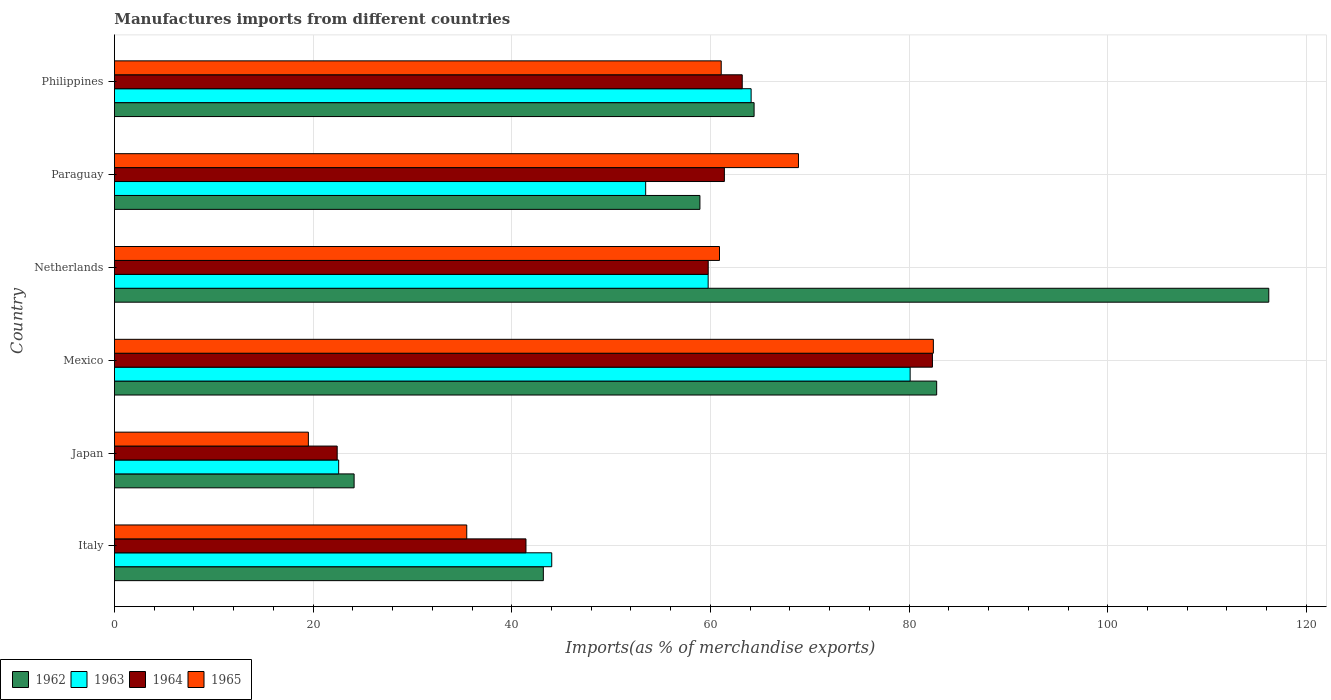How many different coloured bars are there?
Offer a terse response. 4. How many groups of bars are there?
Provide a succinct answer. 6. Are the number of bars per tick equal to the number of legend labels?
Give a very brief answer. Yes. How many bars are there on the 3rd tick from the top?
Offer a very short reply. 4. How many bars are there on the 4th tick from the bottom?
Give a very brief answer. 4. What is the label of the 4th group of bars from the top?
Your response must be concise. Mexico. What is the percentage of imports to different countries in 1964 in Italy?
Your answer should be compact. 41.43. Across all countries, what is the maximum percentage of imports to different countries in 1964?
Provide a succinct answer. 82.35. Across all countries, what is the minimum percentage of imports to different countries in 1962?
Your answer should be very brief. 24.13. In which country was the percentage of imports to different countries in 1965 maximum?
Your answer should be compact. Mexico. In which country was the percentage of imports to different countries in 1964 minimum?
Make the answer very short. Japan. What is the total percentage of imports to different countries in 1963 in the graph?
Offer a terse response. 324.06. What is the difference between the percentage of imports to different countries in 1962 in Japan and that in Paraguay?
Ensure brevity in your answer.  -34.81. What is the difference between the percentage of imports to different countries in 1963 in Italy and the percentage of imports to different countries in 1962 in Mexico?
Offer a very short reply. -38.75. What is the average percentage of imports to different countries in 1965 per country?
Give a very brief answer. 54.72. What is the difference between the percentage of imports to different countries in 1963 and percentage of imports to different countries in 1962 in Japan?
Give a very brief answer. -1.55. In how many countries, is the percentage of imports to different countries in 1962 greater than 92 %?
Your answer should be compact. 1. What is the ratio of the percentage of imports to different countries in 1963 in Netherlands to that in Paraguay?
Make the answer very short. 1.12. Is the percentage of imports to different countries in 1964 in Italy less than that in Netherlands?
Provide a short and direct response. Yes. What is the difference between the highest and the second highest percentage of imports to different countries in 1963?
Your response must be concise. 16.01. What is the difference between the highest and the lowest percentage of imports to different countries in 1965?
Provide a short and direct response. 62.92. In how many countries, is the percentage of imports to different countries in 1963 greater than the average percentage of imports to different countries in 1963 taken over all countries?
Your response must be concise. 3. Is it the case that in every country, the sum of the percentage of imports to different countries in 1965 and percentage of imports to different countries in 1962 is greater than the sum of percentage of imports to different countries in 1964 and percentage of imports to different countries in 1963?
Your response must be concise. No. What does the 4th bar from the top in Netherlands represents?
Provide a short and direct response. 1962. How many bars are there?
Offer a terse response. 24. How many countries are there in the graph?
Offer a terse response. 6. What is the difference between two consecutive major ticks on the X-axis?
Ensure brevity in your answer.  20. Does the graph contain any zero values?
Provide a short and direct response. No. Does the graph contain grids?
Keep it short and to the point. Yes. Where does the legend appear in the graph?
Provide a succinct answer. Bottom left. What is the title of the graph?
Keep it short and to the point. Manufactures imports from different countries. Does "1994" appear as one of the legend labels in the graph?
Ensure brevity in your answer.  No. What is the label or title of the X-axis?
Your answer should be compact. Imports(as % of merchandise exports). What is the label or title of the Y-axis?
Offer a very short reply. Country. What is the Imports(as % of merchandise exports) in 1962 in Italy?
Your response must be concise. 43.18. What is the Imports(as % of merchandise exports) in 1963 in Italy?
Provide a succinct answer. 44.02. What is the Imports(as % of merchandise exports) of 1964 in Italy?
Offer a very short reply. 41.43. What is the Imports(as % of merchandise exports) in 1965 in Italy?
Your response must be concise. 35.47. What is the Imports(as % of merchandise exports) of 1962 in Japan?
Keep it short and to the point. 24.13. What is the Imports(as % of merchandise exports) of 1963 in Japan?
Offer a very short reply. 22.57. What is the Imports(as % of merchandise exports) of 1964 in Japan?
Your answer should be very brief. 22.43. What is the Imports(as % of merchandise exports) of 1965 in Japan?
Offer a terse response. 19.52. What is the Imports(as % of merchandise exports) of 1962 in Mexico?
Provide a short and direct response. 82.78. What is the Imports(as % of merchandise exports) of 1963 in Mexico?
Ensure brevity in your answer.  80.11. What is the Imports(as % of merchandise exports) in 1964 in Mexico?
Provide a succinct answer. 82.35. What is the Imports(as % of merchandise exports) of 1965 in Mexico?
Offer a very short reply. 82.44. What is the Imports(as % of merchandise exports) in 1962 in Netherlands?
Offer a very short reply. 116.21. What is the Imports(as % of merchandise exports) in 1963 in Netherlands?
Your answer should be very brief. 59.77. What is the Imports(as % of merchandise exports) of 1964 in Netherlands?
Ensure brevity in your answer.  59.78. What is the Imports(as % of merchandise exports) in 1965 in Netherlands?
Give a very brief answer. 60.91. What is the Imports(as % of merchandise exports) in 1962 in Paraguay?
Give a very brief answer. 58.94. What is the Imports(as % of merchandise exports) in 1963 in Paraguay?
Keep it short and to the point. 53.48. What is the Imports(as % of merchandise exports) in 1964 in Paraguay?
Your answer should be very brief. 61.4. What is the Imports(as % of merchandise exports) in 1965 in Paraguay?
Make the answer very short. 68.86. What is the Imports(as % of merchandise exports) in 1962 in Philippines?
Offer a very short reply. 64.4. What is the Imports(as % of merchandise exports) in 1963 in Philippines?
Offer a very short reply. 64.1. What is the Imports(as % of merchandise exports) of 1964 in Philippines?
Ensure brevity in your answer.  63.2. What is the Imports(as % of merchandise exports) of 1965 in Philippines?
Keep it short and to the point. 61.09. Across all countries, what is the maximum Imports(as % of merchandise exports) of 1962?
Your answer should be very brief. 116.21. Across all countries, what is the maximum Imports(as % of merchandise exports) in 1963?
Your answer should be compact. 80.11. Across all countries, what is the maximum Imports(as % of merchandise exports) of 1964?
Offer a terse response. 82.35. Across all countries, what is the maximum Imports(as % of merchandise exports) of 1965?
Offer a very short reply. 82.44. Across all countries, what is the minimum Imports(as % of merchandise exports) in 1962?
Keep it short and to the point. 24.13. Across all countries, what is the minimum Imports(as % of merchandise exports) of 1963?
Offer a terse response. 22.57. Across all countries, what is the minimum Imports(as % of merchandise exports) of 1964?
Offer a very short reply. 22.43. Across all countries, what is the minimum Imports(as % of merchandise exports) of 1965?
Offer a very short reply. 19.52. What is the total Imports(as % of merchandise exports) of 1962 in the graph?
Your response must be concise. 389.64. What is the total Imports(as % of merchandise exports) of 1963 in the graph?
Your answer should be compact. 324.06. What is the total Imports(as % of merchandise exports) in 1964 in the graph?
Provide a succinct answer. 330.59. What is the total Imports(as % of merchandise exports) of 1965 in the graph?
Make the answer very short. 328.3. What is the difference between the Imports(as % of merchandise exports) in 1962 in Italy and that in Japan?
Make the answer very short. 19.05. What is the difference between the Imports(as % of merchandise exports) in 1963 in Italy and that in Japan?
Provide a succinct answer. 21.45. What is the difference between the Imports(as % of merchandise exports) in 1964 in Italy and that in Japan?
Offer a very short reply. 19. What is the difference between the Imports(as % of merchandise exports) in 1965 in Italy and that in Japan?
Offer a terse response. 15.94. What is the difference between the Imports(as % of merchandise exports) in 1962 in Italy and that in Mexico?
Keep it short and to the point. -39.6. What is the difference between the Imports(as % of merchandise exports) of 1963 in Italy and that in Mexico?
Your answer should be very brief. -36.08. What is the difference between the Imports(as % of merchandise exports) of 1964 in Italy and that in Mexico?
Your answer should be compact. -40.92. What is the difference between the Imports(as % of merchandise exports) in 1965 in Italy and that in Mexico?
Give a very brief answer. -46.98. What is the difference between the Imports(as % of merchandise exports) of 1962 in Italy and that in Netherlands?
Give a very brief answer. -73.03. What is the difference between the Imports(as % of merchandise exports) of 1963 in Italy and that in Netherlands?
Provide a short and direct response. -15.75. What is the difference between the Imports(as % of merchandise exports) of 1964 in Italy and that in Netherlands?
Give a very brief answer. -18.35. What is the difference between the Imports(as % of merchandise exports) of 1965 in Italy and that in Netherlands?
Your answer should be very brief. -25.45. What is the difference between the Imports(as % of merchandise exports) of 1962 in Italy and that in Paraguay?
Provide a succinct answer. -15.76. What is the difference between the Imports(as % of merchandise exports) of 1963 in Italy and that in Paraguay?
Offer a terse response. -9.46. What is the difference between the Imports(as % of merchandise exports) in 1964 in Italy and that in Paraguay?
Keep it short and to the point. -19.97. What is the difference between the Imports(as % of merchandise exports) in 1965 in Italy and that in Paraguay?
Make the answer very short. -33.4. What is the difference between the Imports(as % of merchandise exports) of 1962 in Italy and that in Philippines?
Offer a terse response. -21.22. What is the difference between the Imports(as % of merchandise exports) of 1963 in Italy and that in Philippines?
Your answer should be very brief. -20.07. What is the difference between the Imports(as % of merchandise exports) in 1964 in Italy and that in Philippines?
Provide a short and direct response. -21.77. What is the difference between the Imports(as % of merchandise exports) in 1965 in Italy and that in Philippines?
Ensure brevity in your answer.  -25.62. What is the difference between the Imports(as % of merchandise exports) of 1962 in Japan and that in Mexico?
Give a very brief answer. -58.65. What is the difference between the Imports(as % of merchandise exports) in 1963 in Japan and that in Mexico?
Provide a short and direct response. -57.53. What is the difference between the Imports(as % of merchandise exports) in 1964 in Japan and that in Mexico?
Offer a very short reply. -59.92. What is the difference between the Imports(as % of merchandise exports) of 1965 in Japan and that in Mexico?
Your answer should be very brief. -62.92. What is the difference between the Imports(as % of merchandise exports) of 1962 in Japan and that in Netherlands?
Your response must be concise. -92.08. What is the difference between the Imports(as % of merchandise exports) of 1963 in Japan and that in Netherlands?
Make the answer very short. -37.2. What is the difference between the Imports(as % of merchandise exports) in 1964 in Japan and that in Netherlands?
Your answer should be compact. -37.35. What is the difference between the Imports(as % of merchandise exports) in 1965 in Japan and that in Netherlands?
Make the answer very short. -41.39. What is the difference between the Imports(as % of merchandise exports) in 1962 in Japan and that in Paraguay?
Your answer should be very brief. -34.81. What is the difference between the Imports(as % of merchandise exports) of 1963 in Japan and that in Paraguay?
Offer a very short reply. -30.91. What is the difference between the Imports(as % of merchandise exports) of 1964 in Japan and that in Paraguay?
Offer a very short reply. -38.98. What is the difference between the Imports(as % of merchandise exports) of 1965 in Japan and that in Paraguay?
Offer a terse response. -49.34. What is the difference between the Imports(as % of merchandise exports) in 1962 in Japan and that in Philippines?
Your answer should be compact. -40.27. What is the difference between the Imports(as % of merchandise exports) in 1963 in Japan and that in Philippines?
Ensure brevity in your answer.  -41.52. What is the difference between the Imports(as % of merchandise exports) of 1964 in Japan and that in Philippines?
Ensure brevity in your answer.  -40.78. What is the difference between the Imports(as % of merchandise exports) of 1965 in Japan and that in Philippines?
Your response must be concise. -41.56. What is the difference between the Imports(as % of merchandise exports) of 1962 in Mexico and that in Netherlands?
Make the answer very short. -33.43. What is the difference between the Imports(as % of merchandise exports) of 1963 in Mexico and that in Netherlands?
Give a very brief answer. 20.34. What is the difference between the Imports(as % of merchandise exports) in 1964 in Mexico and that in Netherlands?
Your answer should be very brief. 22.57. What is the difference between the Imports(as % of merchandise exports) in 1965 in Mexico and that in Netherlands?
Provide a short and direct response. 21.53. What is the difference between the Imports(as % of merchandise exports) of 1962 in Mexico and that in Paraguay?
Your answer should be compact. 23.83. What is the difference between the Imports(as % of merchandise exports) of 1963 in Mexico and that in Paraguay?
Your answer should be compact. 26.63. What is the difference between the Imports(as % of merchandise exports) in 1964 in Mexico and that in Paraguay?
Your answer should be very brief. 20.95. What is the difference between the Imports(as % of merchandise exports) in 1965 in Mexico and that in Paraguay?
Your answer should be compact. 13.58. What is the difference between the Imports(as % of merchandise exports) in 1962 in Mexico and that in Philippines?
Provide a short and direct response. 18.38. What is the difference between the Imports(as % of merchandise exports) of 1963 in Mexico and that in Philippines?
Your response must be concise. 16.01. What is the difference between the Imports(as % of merchandise exports) in 1964 in Mexico and that in Philippines?
Keep it short and to the point. 19.15. What is the difference between the Imports(as % of merchandise exports) in 1965 in Mexico and that in Philippines?
Your response must be concise. 21.36. What is the difference between the Imports(as % of merchandise exports) in 1962 in Netherlands and that in Paraguay?
Keep it short and to the point. 57.27. What is the difference between the Imports(as % of merchandise exports) of 1963 in Netherlands and that in Paraguay?
Provide a succinct answer. 6.29. What is the difference between the Imports(as % of merchandise exports) of 1964 in Netherlands and that in Paraguay?
Your answer should be very brief. -1.63. What is the difference between the Imports(as % of merchandise exports) in 1965 in Netherlands and that in Paraguay?
Give a very brief answer. -7.95. What is the difference between the Imports(as % of merchandise exports) in 1962 in Netherlands and that in Philippines?
Provide a succinct answer. 51.81. What is the difference between the Imports(as % of merchandise exports) in 1963 in Netherlands and that in Philippines?
Keep it short and to the point. -4.33. What is the difference between the Imports(as % of merchandise exports) of 1964 in Netherlands and that in Philippines?
Your answer should be compact. -3.42. What is the difference between the Imports(as % of merchandise exports) of 1965 in Netherlands and that in Philippines?
Your answer should be very brief. -0.17. What is the difference between the Imports(as % of merchandise exports) of 1962 in Paraguay and that in Philippines?
Your response must be concise. -5.45. What is the difference between the Imports(as % of merchandise exports) in 1963 in Paraguay and that in Philippines?
Offer a terse response. -10.62. What is the difference between the Imports(as % of merchandise exports) in 1964 in Paraguay and that in Philippines?
Provide a succinct answer. -1.8. What is the difference between the Imports(as % of merchandise exports) of 1965 in Paraguay and that in Philippines?
Give a very brief answer. 7.78. What is the difference between the Imports(as % of merchandise exports) of 1962 in Italy and the Imports(as % of merchandise exports) of 1963 in Japan?
Your answer should be very brief. 20.61. What is the difference between the Imports(as % of merchandise exports) in 1962 in Italy and the Imports(as % of merchandise exports) in 1964 in Japan?
Your response must be concise. 20.75. What is the difference between the Imports(as % of merchandise exports) in 1962 in Italy and the Imports(as % of merchandise exports) in 1965 in Japan?
Provide a short and direct response. 23.66. What is the difference between the Imports(as % of merchandise exports) in 1963 in Italy and the Imports(as % of merchandise exports) in 1964 in Japan?
Your answer should be compact. 21.6. What is the difference between the Imports(as % of merchandise exports) of 1963 in Italy and the Imports(as % of merchandise exports) of 1965 in Japan?
Make the answer very short. 24.5. What is the difference between the Imports(as % of merchandise exports) in 1964 in Italy and the Imports(as % of merchandise exports) in 1965 in Japan?
Ensure brevity in your answer.  21.91. What is the difference between the Imports(as % of merchandise exports) in 1962 in Italy and the Imports(as % of merchandise exports) in 1963 in Mexico?
Provide a succinct answer. -36.93. What is the difference between the Imports(as % of merchandise exports) of 1962 in Italy and the Imports(as % of merchandise exports) of 1964 in Mexico?
Offer a very short reply. -39.17. What is the difference between the Imports(as % of merchandise exports) in 1962 in Italy and the Imports(as % of merchandise exports) in 1965 in Mexico?
Make the answer very short. -39.26. What is the difference between the Imports(as % of merchandise exports) of 1963 in Italy and the Imports(as % of merchandise exports) of 1964 in Mexico?
Your answer should be compact. -38.33. What is the difference between the Imports(as % of merchandise exports) of 1963 in Italy and the Imports(as % of merchandise exports) of 1965 in Mexico?
Your answer should be compact. -38.42. What is the difference between the Imports(as % of merchandise exports) of 1964 in Italy and the Imports(as % of merchandise exports) of 1965 in Mexico?
Keep it short and to the point. -41.01. What is the difference between the Imports(as % of merchandise exports) in 1962 in Italy and the Imports(as % of merchandise exports) in 1963 in Netherlands?
Your response must be concise. -16.59. What is the difference between the Imports(as % of merchandise exports) of 1962 in Italy and the Imports(as % of merchandise exports) of 1964 in Netherlands?
Your answer should be very brief. -16.6. What is the difference between the Imports(as % of merchandise exports) of 1962 in Italy and the Imports(as % of merchandise exports) of 1965 in Netherlands?
Your answer should be very brief. -17.73. What is the difference between the Imports(as % of merchandise exports) in 1963 in Italy and the Imports(as % of merchandise exports) in 1964 in Netherlands?
Offer a terse response. -15.75. What is the difference between the Imports(as % of merchandise exports) of 1963 in Italy and the Imports(as % of merchandise exports) of 1965 in Netherlands?
Your response must be concise. -16.89. What is the difference between the Imports(as % of merchandise exports) of 1964 in Italy and the Imports(as % of merchandise exports) of 1965 in Netherlands?
Ensure brevity in your answer.  -19.48. What is the difference between the Imports(as % of merchandise exports) of 1962 in Italy and the Imports(as % of merchandise exports) of 1963 in Paraguay?
Your response must be concise. -10.3. What is the difference between the Imports(as % of merchandise exports) in 1962 in Italy and the Imports(as % of merchandise exports) in 1964 in Paraguay?
Make the answer very short. -18.22. What is the difference between the Imports(as % of merchandise exports) in 1962 in Italy and the Imports(as % of merchandise exports) in 1965 in Paraguay?
Your answer should be very brief. -25.68. What is the difference between the Imports(as % of merchandise exports) of 1963 in Italy and the Imports(as % of merchandise exports) of 1964 in Paraguay?
Provide a short and direct response. -17.38. What is the difference between the Imports(as % of merchandise exports) in 1963 in Italy and the Imports(as % of merchandise exports) in 1965 in Paraguay?
Give a very brief answer. -24.84. What is the difference between the Imports(as % of merchandise exports) in 1964 in Italy and the Imports(as % of merchandise exports) in 1965 in Paraguay?
Offer a very short reply. -27.43. What is the difference between the Imports(as % of merchandise exports) of 1962 in Italy and the Imports(as % of merchandise exports) of 1963 in Philippines?
Provide a short and direct response. -20.92. What is the difference between the Imports(as % of merchandise exports) in 1962 in Italy and the Imports(as % of merchandise exports) in 1964 in Philippines?
Your response must be concise. -20.02. What is the difference between the Imports(as % of merchandise exports) in 1962 in Italy and the Imports(as % of merchandise exports) in 1965 in Philippines?
Your answer should be compact. -17.91. What is the difference between the Imports(as % of merchandise exports) of 1963 in Italy and the Imports(as % of merchandise exports) of 1964 in Philippines?
Give a very brief answer. -19.18. What is the difference between the Imports(as % of merchandise exports) in 1963 in Italy and the Imports(as % of merchandise exports) in 1965 in Philippines?
Provide a succinct answer. -17.06. What is the difference between the Imports(as % of merchandise exports) in 1964 in Italy and the Imports(as % of merchandise exports) in 1965 in Philippines?
Keep it short and to the point. -19.66. What is the difference between the Imports(as % of merchandise exports) in 1962 in Japan and the Imports(as % of merchandise exports) in 1963 in Mexico?
Provide a short and direct response. -55.98. What is the difference between the Imports(as % of merchandise exports) of 1962 in Japan and the Imports(as % of merchandise exports) of 1964 in Mexico?
Provide a short and direct response. -58.22. What is the difference between the Imports(as % of merchandise exports) of 1962 in Japan and the Imports(as % of merchandise exports) of 1965 in Mexico?
Make the answer very short. -58.32. What is the difference between the Imports(as % of merchandise exports) in 1963 in Japan and the Imports(as % of merchandise exports) in 1964 in Mexico?
Make the answer very short. -59.78. What is the difference between the Imports(as % of merchandise exports) in 1963 in Japan and the Imports(as % of merchandise exports) in 1965 in Mexico?
Your answer should be very brief. -59.87. What is the difference between the Imports(as % of merchandise exports) of 1964 in Japan and the Imports(as % of merchandise exports) of 1965 in Mexico?
Provide a short and direct response. -60.02. What is the difference between the Imports(as % of merchandise exports) of 1962 in Japan and the Imports(as % of merchandise exports) of 1963 in Netherlands?
Offer a terse response. -35.64. What is the difference between the Imports(as % of merchandise exports) in 1962 in Japan and the Imports(as % of merchandise exports) in 1964 in Netherlands?
Keep it short and to the point. -35.65. What is the difference between the Imports(as % of merchandise exports) of 1962 in Japan and the Imports(as % of merchandise exports) of 1965 in Netherlands?
Your response must be concise. -36.79. What is the difference between the Imports(as % of merchandise exports) of 1963 in Japan and the Imports(as % of merchandise exports) of 1964 in Netherlands?
Ensure brevity in your answer.  -37.2. What is the difference between the Imports(as % of merchandise exports) in 1963 in Japan and the Imports(as % of merchandise exports) in 1965 in Netherlands?
Provide a succinct answer. -38.34. What is the difference between the Imports(as % of merchandise exports) in 1964 in Japan and the Imports(as % of merchandise exports) in 1965 in Netherlands?
Give a very brief answer. -38.49. What is the difference between the Imports(as % of merchandise exports) of 1962 in Japan and the Imports(as % of merchandise exports) of 1963 in Paraguay?
Provide a succinct answer. -29.35. What is the difference between the Imports(as % of merchandise exports) of 1962 in Japan and the Imports(as % of merchandise exports) of 1964 in Paraguay?
Give a very brief answer. -37.28. What is the difference between the Imports(as % of merchandise exports) in 1962 in Japan and the Imports(as % of merchandise exports) in 1965 in Paraguay?
Offer a very short reply. -44.74. What is the difference between the Imports(as % of merchandise exports) in 1963 in Japan and the Imports(as % of merchandise exports) in 1964 in Paraguay?
Make the answer very short. -38.83. What is the difference between the Imports(as % of merchandise exports) of 1963 in Japan and the Imports(as % of merchandise exports) of 1965 in Paraguay?
Give a very brief answer. -46.29. What is the difference between the Imports(as % of merchandise exports) in 1964 in Japan and the Imports(as % of merchandise exports) in 1965 in Paraguay?
Your answer should be very brief. -46.44. What is the difference between the Imports(as % of merchandise exports) of 1962 in Japan and the Imports(as % of merchandise exports) of 1963 in Philippines?
Make the answer very short. -39.97. What is the difference between the Imports(as % of merchandise exports) in 1962 in Japan and the Imports(as % of merchandise exports) in 1964 in Philippines?
Make the answer very short. -39.07. What is the difference between the Imports(as % of merchandise exports) in 1962 in Japan and the Imports(as % of merchandise exports) in 1965 in Philippines?
Ensure brevity in your answer.  -36.96. What is the difference between the Imports(as % of merchandise exports) in 1963 in Japan and the Imports(as % of merchandise exports) in 1964 in Philippines?
Offer a very short reply. -40.63. What is the difference between the Imports(as % of merchandise exports) of 1963 in Japan and the Imports(as % of merchandise exports) of 1965 in Philippines?
Your answer should be compact. -38.51. What is the difference between the Imports(as % of merchandise exports) in 1964 in Japan and the Imports(as % of merchandise exports) in 1965 in Philippines?
Offer a very short reply. -38.66. What is the difference between the Imports(as % of merchandise exports) of 1962 in Mexico and the Imports(as % of merchandise exports) of 1963 in Netherlands?
Your answer should be very brief. 23.01. What is the difference between the Imports(as % of merchandise exports) in 1962 in Mexico and the Imports(as % of merchandise exports) in 1964 in Netherlands?
Give a very brief answer. 23. What is the difference between the Imports(as % of merchandise exports) in 1962 in Mexico and the Imports(as % of merchandise exports) in 1965 in Netherlands?
Provide a succinct answer. 21.86. What is the difference between the Imports(as % of merchandise exports) of 1963 in Mexico and the Imports(as % of merchandise exports) of 1964 in Netherlands?
Offer a very short reply. 20.33. What is the difference between the Imports(as % of merchandise exports) in 1963 in Mexico and the Imports(as % of merchandise exports) in 1965 in Netherlands?
Offer a terse response. 19.19. What is the difference between the Imports(as % of merchandise exports) of 1964 in Mexico and the Imports(as % of merchandise exports) of 1965 in Netherlands?
Provide a succinct answer. 21.44. What is the difference between the Imports(as % of merchandise exports) of 1962 in Mexico and the Imports(as % of merchandise exports) of 1963 in Paraguay?
Your answer should be compact. 29.3. What is the difference between the Imports(as % of merchandise exports) in 1962 in Mexico and the Imports(as % of merchandise exports) in 1964 in Paraguay?
Your response must be concise. 21.37. What is the difference between the Imports(as % of merchandise exports) in 1962 in Mexico and the Imports(as % of merchandise exports) in 1965 in Paraguay?
Your response must be concise. 13.91. What is the difference between the Imports(as % of merchandise exports) of 1963 in Mexico and the Imports(as % of merchandise exports) of 1964 in Paraguay?
Make the answer very short. 18.7. What is the difference between the Imports(as % of merchandise exports) of 1963 in Mexico and the Imports(as % of merchandise exports) of 1965 in Paraguay?
Provide a short and direct response. 11.24. What is the difference between the Imports(as % of merchandise exports) of 1964 in Mexico and the Imports(as % of merchandise exports) of 1965 in Paraguay?
Make the answer very short. 13.49. What is the difference between the Imports(as % of merchandise exports) in 1962 in Mexico and the Imports(as % of merchandise exports) in 1963 in Philippines?
Make the answer very short. 18.68. What is the difference between the Imports(as % of merchandise exports) in 1962 in Mexico and the Imports(as % of merchandise exports) in 1964 in Philippines?
Give a very brief answer. 19.57. What is the difference between the Imports(as % of merchandise exports) of 1962 in Mexico and the Imports(as % of merchandise exports) of 1965 in Philippines?
Your response must be concise. 21.69. What is the difference between the Imports(as % of merchandise exports) in 1963 in Mexico and the Imports(as % of merchandise exports) in 1964 in Philippines?
Your response must be concise. 16.9. What is the difference between the Imports(as % of merchandise exports) in 1963 in Mexico and the Imports(as % of merchandise exports) in 1965 in Philippines?
Ensure brevity in your answer.  19.02. What is the difference between the Imports(as % of merchandise exports) of 1964 in Mexico and the Imports(as % of merchandise exports) of 1965 in Philippines?
Make the answer very short. 21.26. What is the difference between the Imports(as % of merchandise exports) of 1962 in Netherlands and the Imports(as % of merchandise exports) of 1963 in Paraguay?
Your answer should be compact. 62.73. What is the difference between the Imports(as % of merchandise exports) in 1962 in Netherlands and the Imports(as % of merchandise exports) in 1964 in Paraguay?
Your answer should be compact. 54.81. What is the difference between the Imports(as % of merchandise exports) in 1962 in Netherlands and the Imports(as % of merchandise exports) in 1965 in Paraguay?
Give a very brief answer. 47.35. What is the difference between the Imports(as % of merchandise exports) of 1963 in Netherlands and the Imports(as % of merchandise exports) of 1964 in Paraguay?
Your answer should be very brief. -1.63. What is the difference between the Imports(as % of merchandise exports) of 1963 in Netherlands and the Imports(as % of merchandise exports) of 1965 in Paraguay?
Your response must be concise. -9.09. What is the difference between the Imports(as % of merchandise exports) of 1964 in Netherlands and the Imports(as % of merchandise exports) of 1965 in Paraguay?
Provide a succinct answer. -9.09. What is the difference between the Imports(as % of merchandise exports) of 1962 in Netherlands and the Imports(as % of merchandise exports) of 1963 in Philippines?
Give a very brief answer. 52.11. What is the difference between the Imports(as % of merchandise exports) of 1962 in Netherlands and the Imports(as % of merchandise exports) of 1964 in Philippines?
Ensure brevity in your answer.  53.01. What is the difference between the Imports(as % of merchandise exports) in 1962 in Netherlands and the Imports(as % of merchandise exports) in 1965 in Philippines?
Provide a short and direct response. 55.12. What is the difference between the Imports(as % of merchandise exports) of 1963 in Netherlands and the Imports(as % of merchandise exports) of 1964 in Philippines?
Ensure brevity in your answer.  -3.43. What is the difference between the Imports(as % of merchandise exports) in 1963 in Netherlands and the Imports(as % of merchandise exports) in 1965 in Philippines?
Ensure brevity in your answer.  -1.32. What is the difference between the Imports(as % of merchandise exports) of 1964 in Netherlands and the Imports(as % of merchandise exports) of 1965 in Philippines?
Your answer should be very brief. -1.31. What is the difference between the Imports(as % of merchandise exports) of 1962 in Paraguay and the Imports(as % of merchandise exports) of 1963 in Philippines?
Provide a succinct answer. -5.15. What is the difference between the Imports(as % of merchandise exports) in 1962 in Paraguay and the Imports(as % of merchandise exports) in 1964 in Philippines?
Your response must be concise. -4.26. What is the difference between the Imports(as % of merchandise exports) in 1962 in Paraguay and the Imports(as % of merchandise exports) in 1965 in Philippines?
Ensure brevity in your answer.  -2.14. What is the difference between the Imports(as % of merchandise exports) of 1963 in Paraguay and the Imports(as % of merchandise exports) of 1964 in Philippines?
Offer a very short reply. -9.72. What is the difference between the Imports(as % of merchandise exports) in 1963 in Paraguay and the Imports(as % of merchandise exports) in 1965 in Philippines?
Your answer should be very brief. -7.61. What is the difference between the Imports(as % of merchandise exports) in 1964 in Paraguay and the Imports(as % of merchandise exports) in 1965 in Philippines?
Your response must be concise. 0.32. What is the average Imports(as % of merchandise exports) in 1962 per country?
Your answer should be compact. 64.94. What is the average Imports(as % of merchandise exports) of 1963 per country?
Your response must be concise. 54.01. What is the average Imports(as % of merchandise exports) in 1964 per country?
Offer a terse response. 55.1. What is the average Imports(as % of merchandise exports) of 1965 per country?
Ensure brevity in your answer.  54.72. What is the difference between the Imports(as % of merchandise exports) of 1962 and Imports(as % of merchandise exports) of 1963 in Italy?
Your answer should be very brief. -0.84. What is the difference between the Imports(as % of merchandise exports) of 1962 and Imports(as % of merchandise exports) of 1964 in Italy?
Your answer should be very brief. 1.75. What is the difference between the Imports(as % of merchandise exports) in 1962 and Imports(as % of merchandise exports) in 1965 in Italy?
Provide a short and direct response. 7.71. What is the difference between the Imports(as % of merchandise exports) in 1963 and Imports(as % of merchandise exports) in 1964 in Italy?
Keep it short and to the point. 2.59. What is the difference between the Imports(as % of merchandise exports) in 1963 and Imports(as % of merchandise exports) in 1965 in Italy?
Offer a very short reply. 8.56. What is the difference between the Imports(as % of merchandise exports) of 1964 and Imports(as % of merchandise exports) of 1965 in Italy?
Offer a terse response. 5.96. What is the difference between the Imports(as % of merchandise exports) in 1962 and Imports(as % of merchandise exports) in 1963 in Japan?
Provide a short and direct response. 1.55. What is the difference between the Imports(as % of merchandise exports) of 1962 and Imports(as % of merchandise exports) of 1964 in Japan?
Ensure brevity in your answer.  1.7. What is the difference between the Imports(as % of merchandise exports) of 1962 and Imports(as % of merchandise exports) of 1965 in Japan?
Ensure brevity in your answer.  4.6. What is the difference between the Imports(as % of merchandise exports) in 1963 and Imports(as % of merchandise exports) in 1964 in Japan?
Provide a succinct answer. 0.15. What is the difference between the Imports(as % of merchandise exports) in 1963 and Imports(as % of merchandise exports) in 1965 in Japan?
Keep it short and to the point. 3.05. What is the difference between the Imports(as % of merchandise exports) of 1964 and Imports(as % of merchandise exports) of 1965 in Japan?
Make the answer very short. 2.9. What is the difference between the Imports(as % of merchandise exports) in 1962 and Imports(as % of merchandise exports) in 1963 in Mexico?
Provide a succinct answer. 2.67. What is the difference between the Imports(as % of merchandise exports) of 1962 and Imports(as % of merchandise exports) of 1964 in Mexico?
Offer a terse response. 0.43. What is the difference between the Imports(as % of merchandise exports) in 1962 and Imports(as % of merchandise exports) in 1965 in Mexico?
Provide a short and direct response. 0.33. What is the difference between the Imports(as % of merchandise exports) in 1963 and Imports(as % of merchandise exports) in 1964 in Mexico?
Offer a very short reply. -2.24. What is the difference between the Imports(as % of merchandise exports) in 1963 and Imports(as % of merchandise exports) in 1965 in Mexico?
Your response must be concise. -2.34. What is the difference between the Imports(as % of merchandise exports) of 1964 and Imports(as % of merchandise exports) of 1965 in Mexico?
Provide a short and direct response. -0.09. What is the difference between the Imports(as % of merchandise exports) in 1962 and Imports(as % of merchandise exports) in 1963 in Netherlands?
Provide a succinct answer. 56.44. What is the difference between the Imports(as % of merchandise exports) of 1962 and Imports(as % of merchandise exports) of 1964 in Netherlands?
Offer a very short reply. 56.43. What is the difference between the Imports(as % of merchandise exports) in 1962 and Imports(as % of merchandise exports) in 1965 in Netherlands?
Your answer should be compact. 55.3. What is the difference between the Imports(as % of merchandise exports) in 1963 and Imports(as % of merchandise exports) in 1964 in Netherlands?
Ensure brevity in your answer.  -0.01. What is the difference between the Imports(as % of merchandise exports) of 1963 and Imports(as % of merchandise exports) of 1965 in Netherlands?
Your response must be concise. -1.14. What is the difference between the Imports(as % of merchandise exports) in 1964 and Imports(as % of merchandise exports) in 1965 in Netherlands?
Offer a terse response. -1.14. What is the difference between the Imports(as % of merchandise exports) of 1962 and Imports(as % of merchandise exports) of 1963 in Paraguay?
Provide a short and direct response. 5.46. What is the difference between the Imports(as % of merchandise exports) in 1962 and Imports(as % of merchandise exports) in 1964 in Paraguay?
Keep it short and to the point. -2.46. What is the difference between the Imports(as % of merchandise exports) in 1962 and Imports(as % of merchandise exports) in 1965 in Paraguay?
Keep it short and to the point. -9.92. What is the difference between the Imports(as % of merchandise exports) in 1963 and Imports(as % of merchandise exports) in 1964 in Paraguay?
Offer a very short reply. -7.92. What is the difference between the Imports(as % of merchandise exports) in 1963 and Imports(as % of merchandise exports) in 1965 in Paraguay?
Your answer should be very brief. -15.38. What is the difference between the Imports(as % of merchandise exports) in 1964 and Imports(as % of merchandise exports) in 1965 in Paraguay?
Offer a terse response. -7.46. What is the difference between the Imports(as % of merchandise exports) in 1962 and Imports(as % of merchandise exports) in 1963 in Philippines?
Provide a short and direct response. 0.3. What is the difference between the Imports(as % of merchandise exports) in 1962 and Imports(as % of merchandise exports) in 1964 in Philippines?
Your response must be concise. 1.19. What is the difference between the Imports(as % of merchandise exports) of 1962 and Imports(as % of merchandise exports) of 1965 in Philippines?
Your response must be concise. 3.31. What is the difference between the Imports(as % of merchandise exports) of 1963 and Imports(as % of merchandise exports) of 1964 in Philippines?
Give a very brief answer. 0.89. What is the difference between the Imports(as % of merchandise exports) in 1963 and Imports(as % of merchandise exports) in 1965 in Philippines?
Your answer should be compact. 3.01. What is the difference between the Imports(as % of merchandise exports) of 1964 and Imports(as % of merchandise exports) of 1965 in Philippines?
Your response must be concise. 2.12. What is the ratio of the Imports(as % of merchandise exports) of 1962 in Italy to that in Japan?
Your answer should be compact. 1.79. What is the ratio of the Imports(as % of merchandise exports) in 1963 in Italy to that in Japan?
Offer a very short reply. 1.95. What is the ratio of the Imports(as % of merchandise exports) of 1964 in Italy to that in Japan?
Offer a terse response. 1.85. What is the ratio of the Imports(as % of merchandise exports) in 1965 in Italy to that in Japan?
Your answer should be compact. 1.82. What is the ratio of the Imports(as % of merchandise exports) in 1962 in Italy to that in Mexico?
Provide a succinct answer. 0.52. What is the ratio of the Imports(as % of merchandise exports) of 1963 in Italy to that in Mexico?
Make the answer very short. 0.55. What is the ratio of the Imports(as % of merchandise exports) in 1964 in Italy to that in Mexico?
Provide a succinct answer. 0.5. What is the ratio of the Imports(as % of merchandise exports) of 1965 in Italy to that in Mexico?
Your response must be concise. 0.43. What is the ratio of the Imports(as % of merchandise exports) in 1962 in Italy to that in Netherlands?
Ensure brevity in your answer.  0.37. What is the ratio of the Imports(as % of merchandise exports) in 1963 in Italy to that in Netherlands?
Your answer should be compact. 0.74. What is the ratio of the Imports(as % of merchandise exports) of 1964 in Italy to that in Netherlands?
Make the answer very short. 0.69. What is the ratio of the Imports(as % of merchandise exports) in 1965 in Italy to that in Netherlands?
Your answer should be compact. 0.58. What is the ratio of the Imports(as % of merchandise exports) of 1962 in Italy to that in Paraguay?
Keep it short and to the point. 0.73. What is the ratio of the Imports(as % of merchandise exports) in 1963 in Italy to that in Paraguay?
Provide a succinct answer. 0.82. What is the ratio of the Imports(as % of merchandise exports) in 1964 in Italy to that in Paraguay?
Provide a short and direct response. 0.67. What is the ratio of the Imports(as % of merchandise exports) in 1965 in Italy to that in Paraguay?
Your answer should be very brief. 0.52. What is the ratio of the Imports(as % of merchandise exports) of 1962 in Italy to that in Philippines?
Offer a terse response. 0.67. What is the ratio of the Imports(as % of merchandise exports) of 1963 in Italy to that in Philippines?
Your response must be concise. 0.69. What is the ratio of the Imports(as % of merchandise exports) in 1964 in Italy to that in Philippines?
Offer a terse response. 0.66. What is the ratio of the Imports(as % of merchandise exports) in 1965 in Italy to that in Philippines?
Offer a terse response. 0.58. What is the ratio of the Imports(as % of merchandise exports) of 1962 in Japan to that in Mexico?
Ensure brevity in your answer.  0.29. What is the ratio of the Imports(as % of merchandise exports) in 1963 in Japan to that in Mexico?
Provide a short and direct response. 0.28. What is the ratio of the Imports(as % of merchandise exports) of 1964 in Japan to that in Mexico?
Your answer should be compact. 0.27. What is the ratio of the Imports(as % of merchandise exports) in 1965 in Japan to that in Mexico?
Offer a terse response. 0.24. What is the ratio of the Imports(as % of merchandise exports) in 1962 in Japan to that in Netherlands?
Offer a terse response. 0.21. What is the ratio of the Imports(as % of merchandise exports) in 1963 in Japan to that in Netherlands?
Make the answer very short. 0.38. What is the ratio of the Imports(as % of merchandise exports) of 1964 in Japan to that in Netherlands?
Provide a short and direct response. 0.38. What is the ratio of the Imports(as % of merchandise exports) in 1965 in Japan to that in Netherlands?
Keep it short and to the point. 0.32. What is the ratio of the Imports(as % of merchandise exports) of 1962 in Japan to that in Paraguay?
Offer a very short reply. 0.41. What is the ratio of the Imports(as % of merchandise exports) of 1963 in Japan to that in Paraguay?
Offer a terse response. 0.42. What is the ratio of the Imports(as % of merchandise exports) in 1964 in Japan to that in Paraguay?
Provide a succinct answer. 0.37. What is the ratio of the Imports(as % of merchandise exports) of 1965 in Japan to that in Paraguay?
Give a very brief answer. 0.28. What is the ratio of the Imports(as % of merchandise exports) in 1962 in Japan to that in Philippines?
Ensure brevity in your answer.  0.37. What is the ratio of the Imports(as % of merchandise exports) in 1963 in Japan to that in Philippines?
Provide a succinct answer. 0.35. What is the ratio of the Imports(as % of merchandise exports) of 1964 in Japan to that in Philippines?
Provide a succinct answer. 0.35. What is the ratio of the Imports(as % of merchandise exports) of 1965 in Japan to that in Philippines?
Offer a terse response. 0.32. What is the ratio of the Imports(as % of merchandise exports) of 1962 in Mexico to that in Netherlands?
Make the answer very short. 0.71. What is the ratio of the Imports(as % of merchandise exports) in 1963 in Mexico to that in Netherlands?
Provide a succinct answer. 1.34. What is the ratio of the Imports(as % of merchandise exports) in 1964 in Mexico to that in Netherlands?
Make the answer very short. 1.38. What is the ratio of the Imports(as % of merchandise exports) in 1965 in Mexico to that in Netherlands?
Ensure brevity in your answer.  1.35. What is the ratio of the Imports(as % of merchandise exports) in 1962 in Mexico to that in Paraguay?
Provide a short and direct response. 1.4. What is the ratio of the Imports(as % of merchandise exports) of 1963 in Mexico to that in Paraguay?
Your answer should be very brief. 1.5. What is the ratio of the Imports(as % of merchandise exports) of 1964 in Mexico to that in Paraguay?
Provide a succinct answer. 1.34. What is the ratio of the Imports(as % of merchandise exports) of 1965 in Mexico to that in Paraguay?
Offer a terse response. 1.2. What is the ratio of the Imports(as % of merchandise exports) in 1962 in Mexico to that in Philippines?
Your answer should be compact. 1.29. What is the ratio of the Imports(as % of merchandise exports) of 1963 in Mexico to that in Philippines?
Ensure brevity in your answer.  1.25. What is the ratio of the Imports(as % of merchandise exports) in 1964 in Mexico to that in Philippines?
Ensure brevity in your answer.  1.3. What is the ratio of the Imports(as % of merchandise exports) of 1965 in Mexico to that in Philippines?
Offer a terse response. 1.35. What is the ratio of the Imports(as % of merchandise exports) of 1962 in Netherlands to that in Paraguay?
Provide a short and direct response. 1.97. What is the ratio of the Imports(as % of merchandise exports) of 1963 in Netherlands to that in Paraguay?
Ensure brevity in your answer.  1.12. What is the ratio of the Imports(as % of merchandise exports) in 1964 in Netherlands to that in Paraguay?
Offer a terse response. 0.97. What is the ratio of the Imports(as % of merchandise exports) in 1965 in Netherlands to that in Paraguay?
Ensure brevity in your answer.  0.88. What is the ratio of the Imports(as % of merchandise exports) of 1962 in Netherlands to that in Philippines?
Make the answer very short. 1.8. What is the ratio of the Imports(as % of merchandise exports) of 1963 in Netherlands to that in Philippines?
Offer a very short reply. 0.93. What is the ratio of the Imports(as % of merchandise exports) of 1964 in Netherlands to that in Philippines?
Provide a succinct answer. 0.95. What is the ratio of the Imports(as % of merchandise exports) in 1962 in Paraguay to that in Philippines?
Your answer should be compact. 0.92. What is the ratio of the Imports(as % of merchandise exports) of 1963 in Paraguay to that in Philippines?
Keep it short and to the point. 0.83. What is the ratio of the Imports(as % of merchandise exports) of 1964 in Paraguay to that in Philippines?
Offer a terse response. 0.97. What is the ratio of the Imports(as % of merchandise exports) in 1965 in Paraguay to that in Philippines?
Your answer should be very brief. 1.13. What is the difference between the highest and the second highest Imports(as % of merchandise exports) in 1962?
Your answer should be very brief. 33.43. What is the difference between the highest and the second highest Imports(as % of merchandise exports) of 1963?
Offer a very short reply. 16.01. What is the difference between the highest and the second highest Imports(as % of merchandise exports) of 1964?
Provide a succinct answer. 19.15. What is the difference between the highest and the second highest Imports(as % of merchandise exports) of 1965?
Keep it short and to the point. 13.58. What is the difference between the highest and the lowest Imports(as % of merchandise exports) in 1962?
Offer a very short reply. 92.08. What is the difference between the highest and the lowest Imports(as % of merchandise exports) of 1963?
Your answer should be very brief. 57.53. What is the difference between the highest and the lowest Imports(as % of merchandise exports) in 1964?
Provide a short and direct response. 59.92. What is the difference between the highest and the lowest Imports(as % of merchandise exports) of 1965?
Your answer should be very brief. 62.92. 